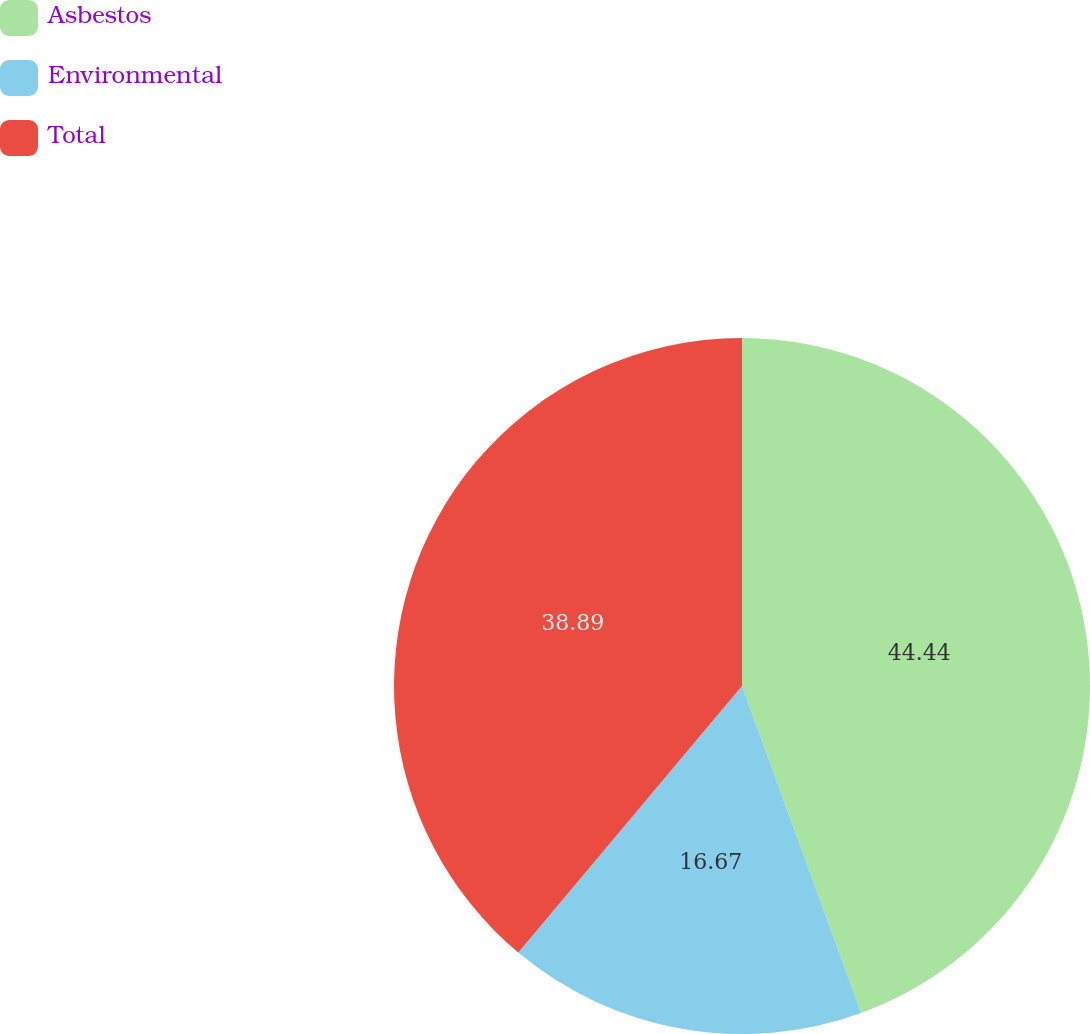<chart> <loc_0><loc_0><loc_500><loc_500><pie_chart><fcel>Asbestos<fcel>Environmental<fcel>Total<nl><fcel>44.44%<fcel>16.67%<fcel>38.89%<nl></chart> 